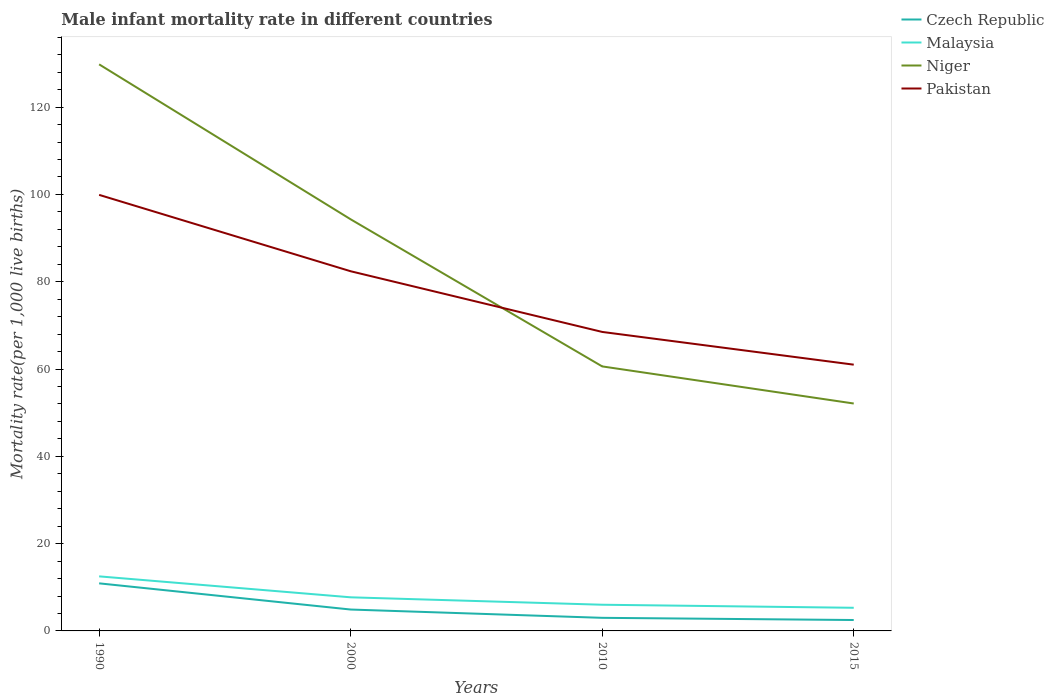How many different coloured lines are there?
Your response must be concise. 4. Is the number of lines equal to the number of legend labels?
Give a very brief answer. Yes. Across all years, what is the maximum male infant mortality rate in Niger?
Make the answer very short. 52.1. In which year was the male infant mortality rate in Malaysia maximum?
Provide a short and direct response. 2015. What is the total male infant mortality rate in Niger in the graph?
Offer a terse response. 69.2. What is the difference between the highest and the second highest male infant mortality rate in Pakistan?
Offer a terse response. 38.9. What is the difference between the highest and the lowest male infant mortality rate in Pakistan?
Keep it short and to the point. 2. How many lines are there?
Provide a succinct answer. 4. What is the difference between two consecutive major ticks on the Y-axis?
Keep it short and to the point. 20. Are the values on the major ticks of Y-axis written in scientific E-notation?
Ensure brevity in your answer.  No. Does the graph contain grids?
Make the answer very short. No. How are the legend labels stacked?
Ensure brevity in your answer.  Vertical. What is the title of the graph?
Provide a succinct answer. Male infant mortality rate in different countries. Does "Europe(all income levels)" appear as one of the legend labels in the graph?
Ensure brevity in your answer.  No. What is the label or title of the Y-axis?
Your response must be concise. Mortality rate(per 1,0 live births). What is the Mortality rate(per 1,000 live births) in Niger in 1990?
Make the answer very short. 129.8. What is the Mortality rate(per 1,000 live births) in Pakistan in 1990?
Offer a very short reply. 99.9. What is the Mortality rate(per 1,000 live births) in Niger in 2000?
Provide a short and direct response. 94.3. What is the Mortality rate(per 1,000 live births) in Pakistan in 2000?
Keep it short and to the point. 82.4. What is the Mortality rate(per 1,000 live births) of Czech Republic in 2010?
Offer a terse response. 3. What is the Mortality rate(per 1,000 live births) of Niger in 2010?
Provide a short and direct response. 60.6. What is the Mortality rate(per 1,000 live births) in Pakistan in 2010?
Offer a terse response. 68.5. What is the Mortality rate(per 1,000 live births) of Niger in 2015?
Your response must be concise. 52.1. What is the Mortality rate(per 1,000 live births) of Pakistan in 2015?
Keep it short and to the point. 61. Across all years, what is the maximum Mortality rate(per 1,000 live births) in Czech Republic?
Your answer should be compact. 10.9. Across all years, what is the maximum Mortality rate(per 1,000 live births) of Malaysia?
Offer a very short reply. 12.5. Across all years, what is the maximum Mortality rate(per 1,000 live births) of Niger?
Make the answer very short. 129.8. Across all years, what is the maximum Mortality rate(per 1,000 live births) in Pakistan?
Your answer should be very brief. 99.9. Across all years, what is the minimum Mortality rate(per 1,000 live births) in Malaysia?
Your answer should be very brief. 5.3. Across all years, what is the minimum Mortality rate(per 1,000 live births) in Niger?
Give a very brief answer. 52.1. What is the total Mortality rate(per 1,000 live births) in Czech Republic in the graph?
Your answer should be very brief. 21.3. What is the total Mortality rate(per 1,000 live births) of Malaysia in the graph?
Your answer should be very brief. 31.5. What is the total Mortality rate(per 1,000 live births) of Niger in the graph?
Make the answer very short. 336.8. What is the total Mortality rate(per 1,000 live births) of Pakistan in the graph?
Offer a very short reply. 311.8. What is the difference between the Mortality rate(per 1,000 live births) of Czech Republic in 1990 and that in 2000?
Give a very brief answer. 6. What is the difference between the Mortality rate(per 1,000 live births) in Niger in 1990 and that in 2000?
Your response must be concise. 35.5. What is the difference between the Mortality rate(per 1,000 live births) of Czech Republic in 1990 and that in 2010?
Offer a terse response. 7.9. What is the difference between the Mortality rate(per 1,000 live births) of Malaysia in 1990 and that in 2010?
Ensure brevity in your answer.  6.5. What is the difference between the Mortality rate(per 1,000 live births) in Niger in 1990 and that in 2010?
Give a very brief answer. 69.2. What is the difference between the Mortality rate(per 1,000 live births) in Pakistan in 1990 and that in 2010?
Give a very brief answer. 31.4. What is the difference between the Mortality rate(per 1,000 live births) of Niger in 1990 and that in 2015?
Ensure brevity in your answer.  77.7. What is the difference between the Mortality rate(per 1,000 live births) in Pakistan in 1990 and that in 2015?
Make the answer very short. 38.9. What is the difference between the Mortality rate(per 1,000 live births) of Malaysia in 2000 and that in 2010?
Provide a short and direct response. 1.7. What is the difference between the Mortality rate(per 1,000 live births) of Niger in 2000 and that in 2010?
Offer a terse response. 33.7. What is the difference between the Mortality rate(per 1,000 live births) of Pakistan in 2000 and that in 2010?
Your answer should be very brief. 13.9. What is the difference between the Mortality rate(per 1,000 live births) of Niger in 2000 and that in 2015?
Your answer should be compact. 42.2. What is the difference between the Mortality rate(per 1,000 live births) of Pakistan in 2000 and that in 2015?
Provide a short and direct response. 21.4. What is the difference between the Mortality rate(per 1,000 live births) in Niger in 2010 and that in 2015?
Your response must be concise. 8.5. What is the difference between the Mortality rate(per 1,000 live births) of Czech Republic in 1990 and the Mortality rate(per 1,000 live births) of Niger in 2000?
Provide a succinct answer. -83.4. What is the difference between the Mortality rate(per 1,000 live births) of Czech Republic in 1990 and the Mortality rate(per 1,000 live births) of Pakistan in 2000?
Give a very brief answer. -71.5. What is the difference between the Mortality rate(per 1,000 live births) in Malaysia in 1990 and the Mortality rate(per 1,000 live births) in Niger in 2000?
Your answer should be very brief. -81.8. What is the difference between the Mortality rate(per 1,000 live births) of Malaysia in 1990 and the Mortality rate(per 1,000 live births) of Pakistan in 2000?
Make the answer very short. -69.9. What is the difference between the Mortality rate(per 1,000 live births) in Niger in 1990 and the Mortality rate(per 1,000 live births) in Pakistan in 2000?
Your answer should be very brief. 47.4. What is the difference between the Mortality rate(per 1,000 live births) in Czech Republic in 1990 and the Mortality rate(per 1,000 live births) in Malaysia in 2010?
Your answer should be very brief. 4.9. What is the difference between the Mortality rate(per 1,000 live births) in Czech Republic in 1990 and the Mortality rate(per 1,000 live births) in Niger in 2010?
Your response must be concise. -49.7. What is the difference between the Mortality rate(per 1,000 live births) of Czech Republic in 1990 and the Mortality rate(per 1,000 live births) of Pakistan in 2010?
Your response must be concise. -57.6. What is the difference between the Mortality rate(per 1,000 live births) of Malaysia in 1990 and the Mortality rate(per 1,000 live births) of Niger in 2010?
Make the answer very short. -48.1. What is the difference between the Mortality rate(per 1,000 live births) in Malaysia in 1990 and the Mortality rate(per 1,000 live births) in Pakistan in 2010?
Offer a very short reply. -56. What is the difference between the Mortality rate(per 1,000 live births) in Niger in 1990 and the Mortality rate(per 1,000 live births) in Pakistan in 2010?
Keep it short and to the point. 61.3. What is the difference between the Mortality rate(per 1,000 live births) of Czech Republic in 1990 and the Mortality rate(per 1,000 live births) of Malaysia in 2015?
Provide a succinct answer. 5.6. What is the difference between the Mortality rate(per 1,000 live births) of Czech Republic in 1990 and the Mortality rate(per 1,000 live births) of Niger in 2015?
Ensure brevity in your answer.  -41.2. What is the difference between the Mortality rate(per 1,000 live births) of Czech Republic in 1990 and the Mortality rate(per 1,000 live births) of Pakistan in 2015?
Keep it short and to the point. -50.1. What is the difference between the Mortality rate(per 1,000 live births) of Malaysia in 1990 and the Mortality rate(per 1,000 live births) of Niger in 2015?
Provide a short and direct response. -39.6. What is the difference between the Mortality rate(per 1,000 live births) in Malaysia in 1990 and the Mortality rate(per 1,000 live births) in Pakistan in 2015?
Your response must be concise. -48.5. What is the difference between the Mortality rate(per 1,000 live births) in Niger in 1990 and the Mortality rate(per 1,000 live births) in Pakistan in 2015?
Offer a terse response. 68.8. What is the difference between the Mortality rate(per 1,000 live births) in Czech Republic in 2000 and the Mortality rate(per 1,000 live births) in Malaysia in 2010?
Your answer should be very brief. -1.1. What is the difference between the Mortality rate(per 1,000 live births) of Czech Republic in 2000 and the Mortality rate(per 1,000 live births) of Niger in 2010?
Offer a very short reply. -55.7. What is the difference between the Mortality rate(per 1,000 live births) of Czech Republic in 2000 and the Mortality rate(per 1,000 live births) of Pakistan in 2010?
Your answer should be compact. -63.6. What is the difference between the Mortality rate(per 1,000 live births) of Malaysia in 2000 and the Mortality rate(per 1,000 live births) of Niger in 2010?
Your answer should be very brief. -52.9. What is the difference between the Mortality rate(per 1,000 live births) of Malaysia in 2000 and the Mortality rate(per 1,000 live births) of Pakistan in 2010?
Make the answer very short. -60.8. What is the difference between the Mortality rate(per 1,000 live births) in Niger in 2000 and the Mortality rate(per 1,000 live births) in Pakistan in 2010?
Provide a succinct answer. 25.8. What is the difference between the Mortality rate(per 1,000 live births) of Czech Republic in 2000 and the Mortality rate(per 1,000 live births) of Niger in 2015?
Ensure brevity in your answer.  -47.2. What is the difference between the Mortality rate(per 1,000 live births) of Czech Republic in 2000 and the Mortality rate(per 1,000 live births) of Pakistan in 2015?
Your answer should be compact. -56.1. What is the difference between the Mortality rate(per 1,000 live births) in Malaysia in 2000 and the Mortality rate(per 1,000 live births) in Niger in 2015?
Make the answer very short. -44.4. What is the difference between the Mortality rate(per 1,000 live births) in Malaysia in 2000 and the Mortality rate(per 1,000 live births) in Pakistan in 2015?
Provide a succinct answer. -53.3. What is the difference between the Mortality rate(per 1,000 live births) of Niger in 2000 and the Mortality rate(per 1,000 live births) of Pakistan in 2015?
Your response must be concise. 33.3. What is the difference between the Mortality rate(per 1,000 live births) of Czech Republic in 2010 and the Mortality rate(per 1,000 live births) of Niger in 2015?
Your response must be concise. -49.1. What is the difference between the Mortality rate(per 1,000 live births) in Czech Republic in 2010 and the Mortality rate(per 1,000 live births) in Pakistan in 2015?
Make the answer very short. -58. What is the difference between the Mortality rate(per 1,000 live births) of Malaysia in 2010 and the Mortality rate(per 1,000 live births) of Niger in 2015?
Offer a terse response. -46.1. What is the difference between the Mortality rate(per 1,000 live births) in Malaysia in 2010 and the Mortality rate(per 1,000 live births) in Pakistan in 2015?
Your answer should be very brief. -55. What is the average Mortality rate(per 1,000 live births) of Czech Republic per year?
Your answer should be compact. 5.33. What is the average Mortality rate(per 1,000 live births) of Malaysia per year?
Offer a very short reply. 7.88. What is the average Mortality rate(per 1,000 live births) of Niger per year?
Offer a terse response. 84.2. What is the average Mortality rate(per 1,000 live births) of Pakistan per year?
Provide a succinct answer. 77.95. In the year 1990, what is the difference between the Mortality rate(per 1,000 live births) of Czech Republic and Mortality rate(per 1,000 live births) of Niger?
Ensure brevity in your answer.  -118.9. In the year 1990, what is the difference between the Mortality rate(per 1,000 live births) of Czech Republic and Mortality rate(per 1,000 live births) of Pakistan?
Offer a very short reply. -89. In the year 1990, what is the difference between the Mortality rate(per 1,000 live births) in Malaysia and Mortality rate(per 1,000 live births) in Niger?
Make the answer very short. -117.3. In the year 1990, what is the difference between the Mortality rate(per 1,000 live births) of Malaysia and Mortality rate(per 1,000 live births) of Pakistan?
Make the answer very short. -87.4. In the year 1990, what is the difference between the Mortality rate(per 1,000 live births) in Niger and Mortality rate(per 1,000 live births) in Pakistan?
Keep it short and to the point. 29.9. In the year 2000, what is the difference between the Mortality rate(per 1,000 live births) of Czech Republic and Mortality rate(per 1,000 live births) of Malaysia?
Provide a short and direct response. -2.8. In the year 2000, what is the difference between the Mortality rate(per 1,000 live births) of Czech Republic and Mortality rate(per 1,000 live births) of Niger?
Provide a succinct answer. -89.4. In the year 2000, what is the difference between the Mortality rate(per 1,000 live births) of Czech Republic and Mortality rate(per 1,000 live births) of Pakistan?
Your answer should be very brief. -77.5. In the year 2000, what is the difference between the Mortality rate(per 1,000 live births) in Malaysia and Mortality rate(per 1,000 live births) in Niger?
Provide a succinct answer. -86.6. In the year 2000, what is the difference between the Mortality rate(per 1,000 live births) of Malaysia and Mortality rate(per 1,000 live births) of Pakistan?
Your answer should be compact. -74.7. In the year 2010, what is the difference between the Mortality rate(per 1,000 live births) of Czech Republic and Mortality rate(per 1,000 live births) of Niger?
Your answer should be very brief. -57.6. In the year 2010, what is the difference between the Mortality rate(per 1,000 live births) of Czech Republic and Mortality rate(per 1,000 live births) of Pakistan?
Your answer should be very brief. -65.5. In the year 2010, what is the difference between the Mortality rate(per 1,000 live births) in Malaysia and Mortality rate(per 1,000 live births) in Niger?
Keep it short and to the point. -54.6. In the year 2010, what is the difference between the Mortality rate(per 1,000 live births) in Malaysia and Mortality rate(per 1,000 live births) in Pakistan?
Offer a very short reply. -62.5. In the year 2010, what is the difference between the Mortality rate(per 1,000 live births) in Niger and Mortality rate(per 1,000 live births) in Pakistan?
Keep it short and to the point. -7.9. In the year 2015, what is the difference between the Mortality rate(per 1,000 live births) in Czech Republic and Mortality rate(per 1,000 live births) in Niger?
Ensure brevity in your answer.  -49.6. In the year 2015, what is the difference between the Mortality rate(per 1,000 live births) in Czech Republic and Mortality rate(per 1,000 live births) in Pakistan?
Offer a very short reply. -58.5. In the year 2015, what is the difference between the Mortality rate(per 1,000 live births) of Malaysia and Mortality rate(per 1,000 live births) of Niger?
Provide a succinct answer. -46.8. In the year 2015, what is the difference between the Mortality rate(per 1,000 live births) of Malaysia and Mortality rate(per 1,000 live births) of Pakistan?
Ensure brevity in your answer.  -55.7. What is the ratio of the Mortality rate(per 1,000 live births) of Czech Republic in 1990 to that in 2000?
Provide a short and direct response. 2.22. What is the ratio of the Mortality rate(per 1,000 live births) in Malaysia in 1990 to that in 2000?
Ensure brevity in your answer.  1.62. What is the ratio of the Mortality rate(per 1,000 live births) of Niger in 1990 to that in 2000?
Your response must be concise. 1.38. What is the ratio of the Mortality rate(per 1,000 live births) of Pakistan in 1990 to that in 2000?
Ensure brevity in your answer.  1.21. What is the ratio of the Mortality rate(per 1,000 live births) of Czech Republic in 1990 to that in 2010?
Your response must be concise. 3.63. What is the ratio of the Mortality rate(per 1,000 live births) of Malaysia in 1990 to that in 2010?
Your response must be concise. 2.08. What is the ratio of the Mortality rate(per 1,000 live births) in Niger in 1990 to that in 2010?
Provide a short and direct response. 2.14. What is the ratio of the Mortality rate(per 1,000 live births) in Pakistan in 1990 to that in 2010?
Provide a succinct answer. 1.46. What is the ratio of the Mortality rate(per 1,000 live births) of Czech Republic in 1990 to that in 2015?
Make the answer very short. 4.36. What is the ratio of the Mortality rate(per 1,000 live births) in Malaysia in 1990 to that in 2015?
Keep it short and to the point. 2.36. What is the ratio of the Mortality rate(per 1,000 live births) of Niger in 1990 to that in 2015?
Your response must be concise. 2.49. What is the ratio of the Mortality rate(per 1,000 live births) in Pakistan in 1990 to that in 2015?
Make the answer very short. 1.64. What is the ratio of the Mortality rate(per 1,000 live births) in Czech Republic in 2000 to that in 2010?
Ensure brevity in your answer.  1.63. What is the ratio of the Mortality rate(per 1,000 live births) of Malaysia in 2000 to that in 2010?
Your answer should be compact. 1.28. What is the ratio of the Mortality rate(per 1,000 live births) of Niger in 2000 to that in 2010?
Provide a succinct answer. 1.56. What is the ratio of the Mortality rate(per 1,000 live births) of Pakistan in 2000 to that in 2010?
Your response must be concise. 1.2. What is the ratio of the Mortality rate(per 1,000 live births) in Czech Republic in 2000 to that in 2015?
Provide a succinct answer. 1.96. What is the ratio of the Mortality rate(per 1,000 live births) in Malaysia in 2000 to that in 2015?
Make the answer very short. 1.45. What is the ratio of the Mortality rate(per 1,000 live births) of Niger in 2000 to that in 2015?
Provide a short and direct response. 1.81. What is the ratio of the Mortality rate(per 1,000 live births) of Pakistan in 2000 to that in 2015?
Your answer should be very brief. 1.35. What is the ratio of the Mortality rate(per 1,000 live births) of Malaysia in 2010 to that in 2015?
Ensure brevity in your answer.  1.13. What is the ratio of the Mortality rate(per 1,000 live births) in Niger in 2010 to that in 2015?
Provide a short and direct response. 1.16. What is the ratio of the Mortality rate(per 1,000 live births) of Pakistan in 2010 to that in 2015?
Keep it short and to the point. 1.12. What is the difference between the highest and the second highest Mortality rate(per 1,000 live births) of Czech Republic?
Provide a succinct answer. 6. What is the difference between the highest and the second highest Mortality rate(per 1,000 live births) in Niger?
Your answer should be very brief. 35.5. What is the difference between the highest and the second highest Mortality rate(per 1,000 live births) of Pakistan?
Your answer should be very brief. 17.5. What is the difference between the highest and the lowest Mortality rate(per 1,000 live births) in Czech Republic?
Offer a very short reply. 8.4. What is the difference between the highest and the lowest Mortality rate(per 1,000 live births) of Malaysia?
Your answer should be very brief. 7.2. What is the difference between the highest and the lowest Mortality rate(per 1,000 live births) of Niger?
Provide a short and direct response. 77.7. What is the difference between the highest and the lowest Mortality rate(per 1,000 live births) of Pakistan?
Your response must be concise. 38.9. 